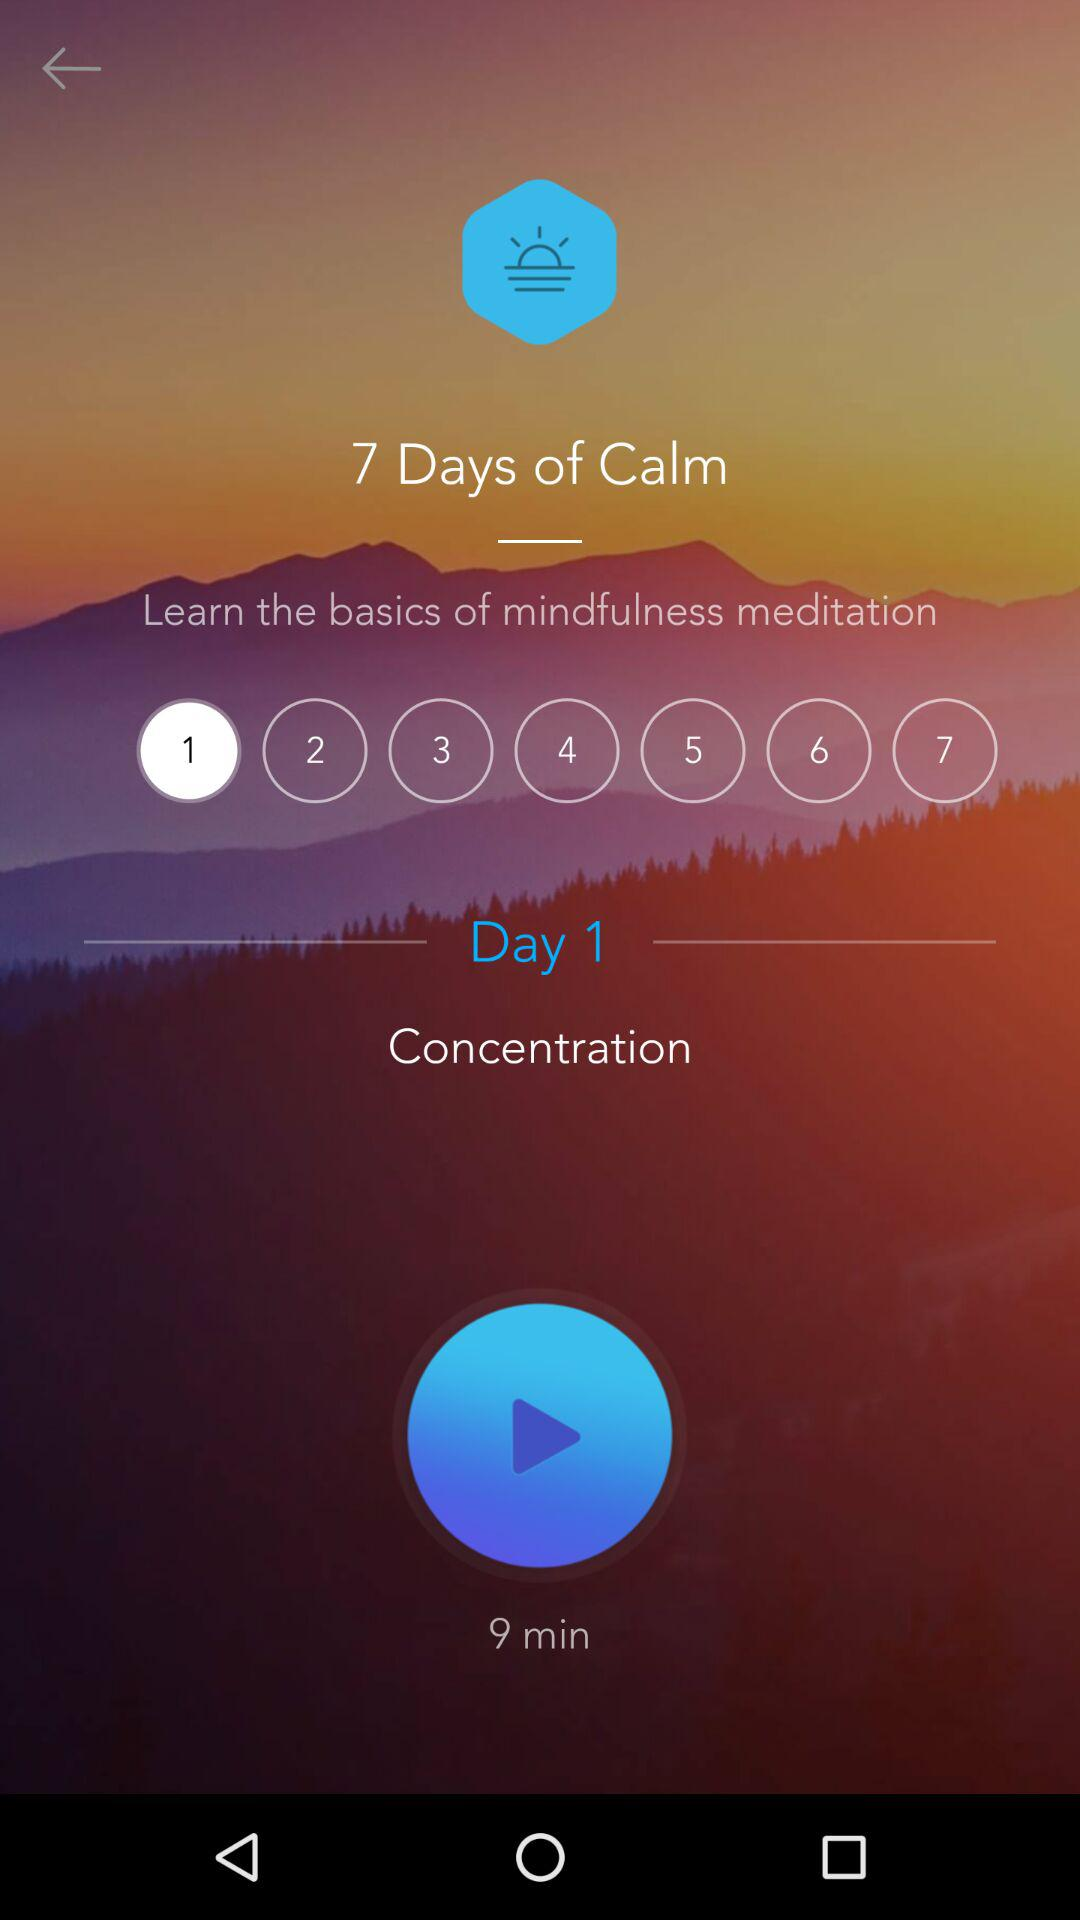Which is the selected day? The selected day is 1. 